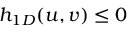<formula> <loc_0><loc_0><loc_500><loc_500>h _ { 1 D } ( u , v ) \leq 0</formula> 